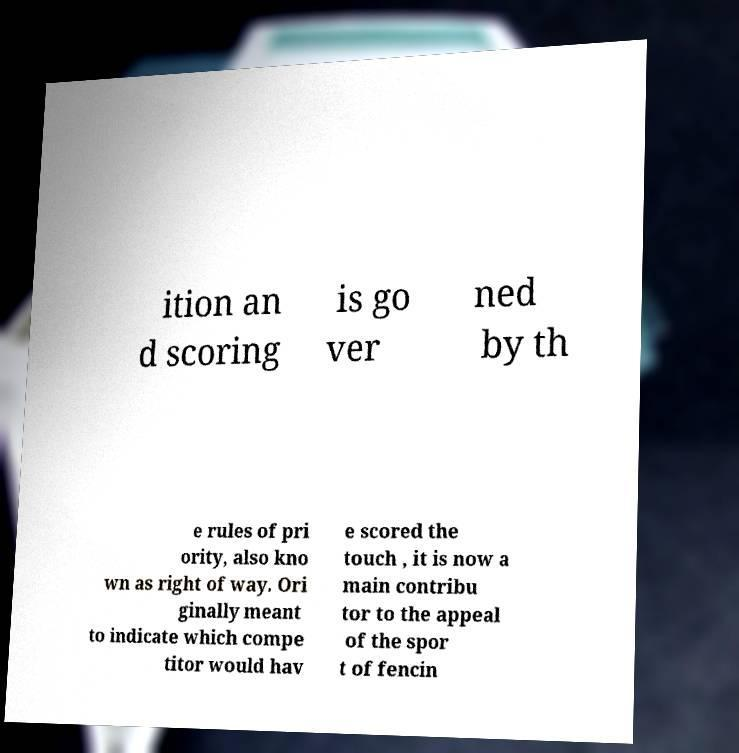I need the written content from this picture converted into text. Can you do that? ition an d scoring is go ver ned by th e rules of pri ority, also kno wn as right of way. Ori ginally meant to indicate which compe titor would hav e scored the touch , it is now a main contribu tor to the appeal of the spor t of fencin 